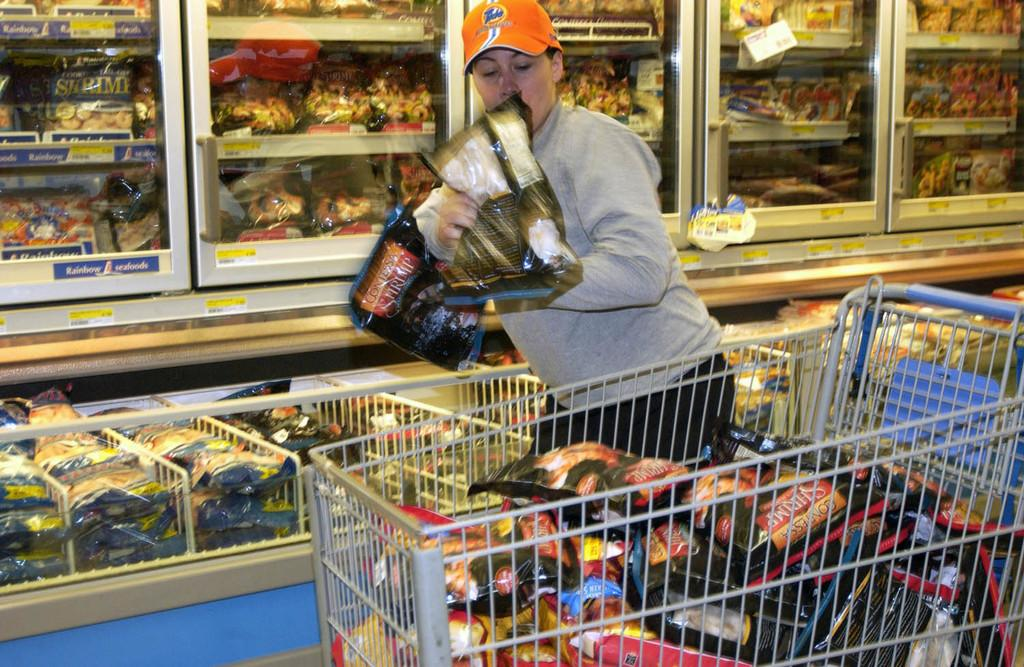Provide a one-sentence caption for the provided image. A woman is shopping and putting Contessa Shrimp bags into her cart. 